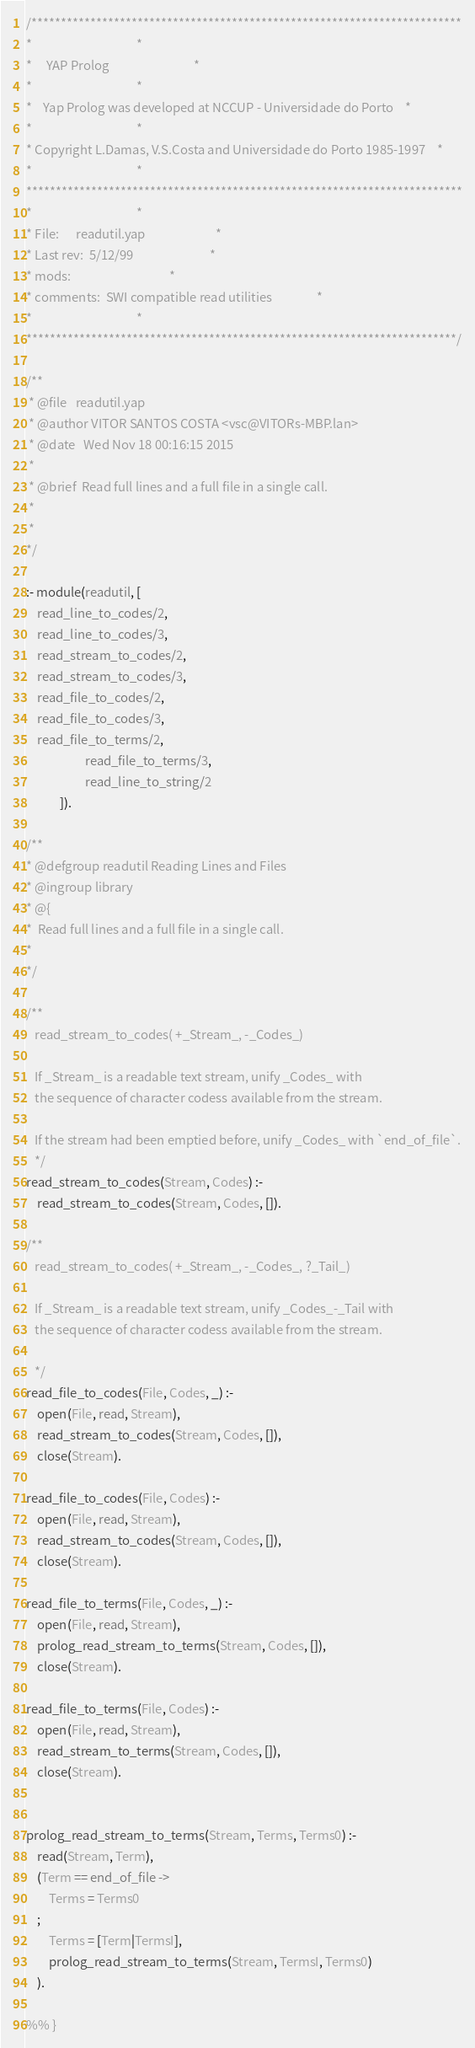<code> <loc_0><loc_0><loc_500><loc_500><_Prolog_>/*************************************************************************
*									 *
*	 YAP Prolog 							 *
*									 *
*	Yap Prolog was developed at NCCUP - Universidade do Porto	 *
*									 *
* Copyright L.Damas, V.S.Costa and Universidade do Porto 1985-1997	 *
*									 *
**************************************************************************
*									 *
* File:		readutil.yap						 *
* Last rev:	5/12/99							 *
* mods:									 *
* comments:	SWI compatible read utilities				 *
*									 *
*************************************************************************/

/**
 * @file   readutil.yap
 * @author VITOR SANTOS COSTA <vsc@VITORs-MBP.lan>
 * @date   Wed Nov 18 00:16:15 2015
 *
 * @brief  Read full lines and a full file in a single call.
 *
 *
*/

:- module(readutil, [
	read_line_to_codes/2,
	read_line_to_codes/3,
	read_stream_to_codes/2,
	read_stream_to_codes/3,
	read_file_to_codes/2,
	read_file_to_codes/3,
	read_file_to_terms/2,
                     read_file_to_terms/3,
                     read_line_to_string/2
		    ]).

/**
* @defgroup readutil Reading Lines and Files
* @ingroup library
* @{
*  Read full lines and a full file in a single call.
*
*/

/**
   read_stream_to_codes( +_Stream_, -_Codes_)

   If _Stream_ is a readable text stream, unify _Codes_ with
   the sequence of character codess available from the stream.

   If the stream had been emptied before, unify _Codes_ with `end_of_file`.
   */
read_stream_to_codes(Stream, Codes) :-
	read_stream_to_codes(Stream, Codes, []).

/**
   read_stream_to_codes( +_Stream_, -_Codes_, ?_Tail_)

   If _Stream_ is a readable text stream, unify _Codes_-_Tail with
   the sequence of character codess available from the stream.

   */
read_file_to_codes(File, Codes, _) :-
	open(File, read, Stream),
	read_stream_to_codes(Stream, Codes, []),
	close(Stream).

read_file_to_codes(File, Codes) :-
	open(File, read, Stream),
	read_stream_to_codes(Stream, Codes, []),
	close(Stream).

read_file_to_terms(File, Codes, _) :-
	open(File, read, Stream),
	prolog_read_stream_to_terms(Stream, Codes, []),
	close(Stream).

read_file_to_terms(File, Codes) :-
	open(File, read, Stream),
	read_stream_to_terms(Stream, Codes, []),
	close(Stream).


prolog_read_stream_to_terms(Stream, Terms, Terms0) :-
	read(Stream, Term),
	(Term == end_of_file ->
	    Terms = Terms0
	;
	    Terms = [Term|TermsI],
	    prolog_read_stream_to_terms(Stream, TermsI, Terms0)
	).

%% }</code> 